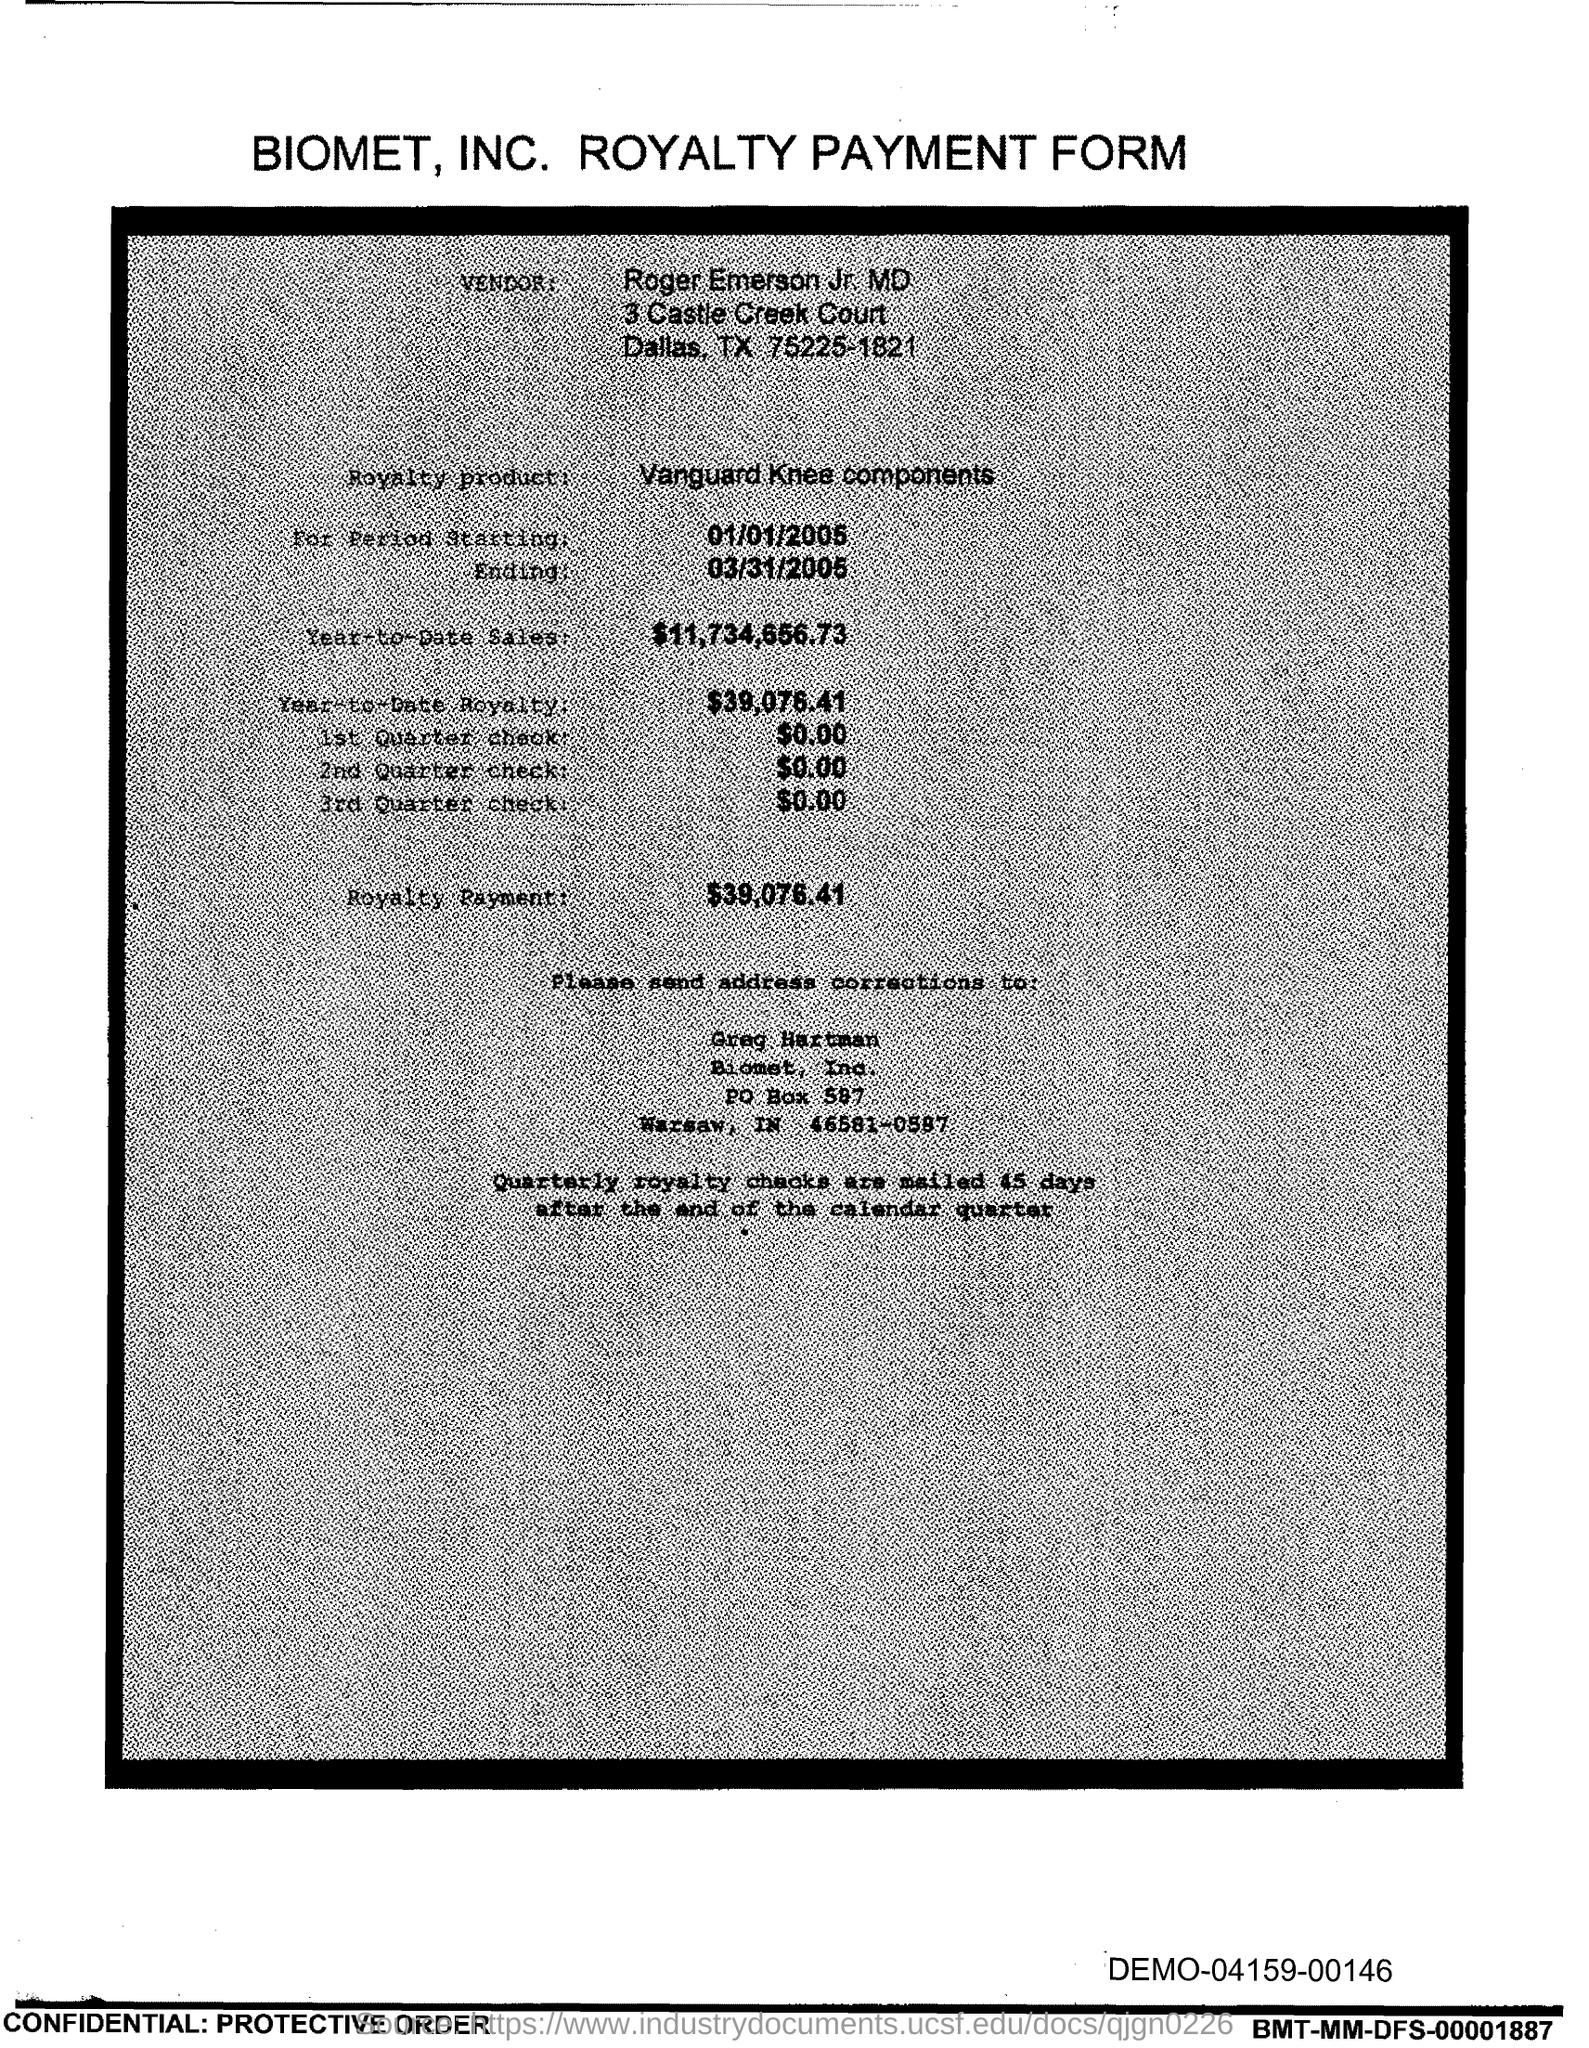Point out several critical features in this image. The end date of the royalty period is March 31, 2005. The royalty product, in the form of Vanguard Knee components, is a feature of our company. The amount of the 3rd Quarter check given in the form is $0.00. Roger Emerson Jr., MD, is the vendor mentioned in the form. The amount mentioned in the 2nd Quarter check form is 0.00. 